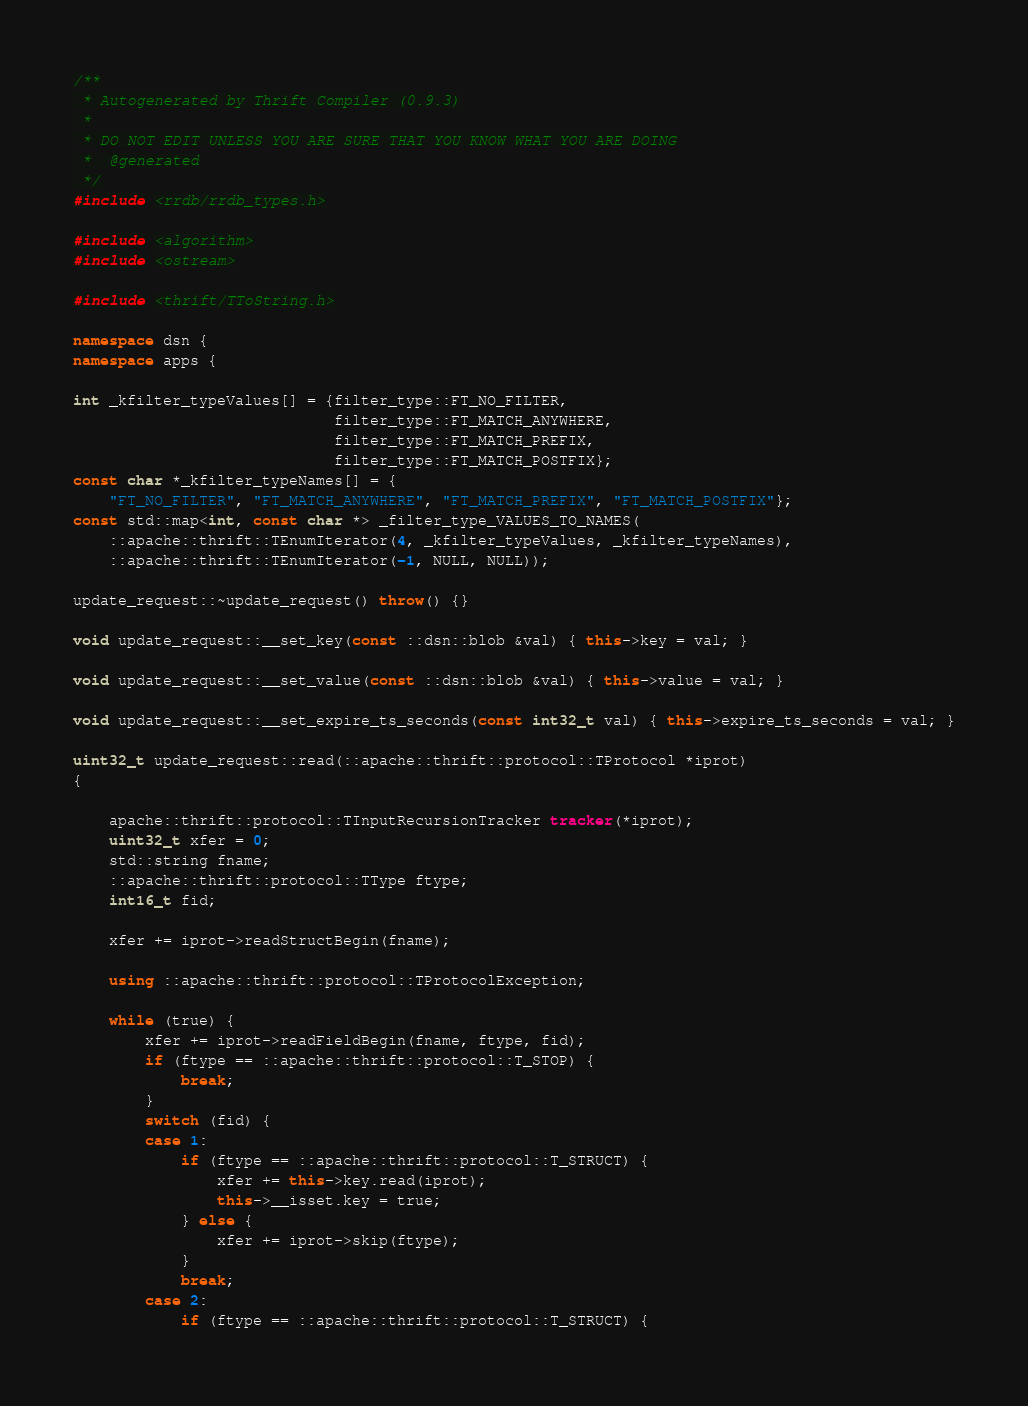Convert code to text. <code><loc_0><loc_0><loc_500><loc_500><_C++_>/**
 * Autogenerated by Thrift Compiler (0.9.3)
 *
 * DO NOT EDIT UNLESS YOU ARE SURE THAT YOU KNOW WHAT YOU ARE DOING
 *  @generated
 */
#include <rrdb/rrdb_types.h>

#include <algorithm>
#include <ostream>

#include <thrift/TToString.h>

namespace dsn {
namespace apps {

int _kfilter_typeValues[] = {filter_type::FT_NO_FILTER,
                             filter_type::FT_MATCH_ANYWHERE,
                             filter_type::FT_MATCH_PREFIX,
                             filter_type::FT_MATCH_POSTFIX};
const char *_kfilter_typeNames[] = {
    "FT_NO_FILTER", "FT_MATCH_ANYWHERE", "FT_MATCH_PREFIX", "FT_MATCH_POSTFIX"};
const std::map<int, const char *> _filter_type_VALUES_TO_NAMES(
    ::apache::thrift::TEnumIterator(4, _kfilter_typeValues, _kfilter_typeNames),
    ::apache::thrift::TEnumIterator(-1, NULL, NULL));

update_request::~update_request() throw() {}

void update_request::__set_key(const ::dsn::blob &val) { this->key = val; }

void update_request::__set_value(const ::dsn::blob &val) { this->value = val; }

void update_request::__set_expire_ts_seconds(const int32_t val) { this->expire_ts_seconds = val; }

uint32_t update_request::read(::apache::thrift::protocol::TProtocol *iprot)
{

    apache::thrift::protocol::TInputRecursionTracker tracker(*iprot);
    uint32_t xfer = 0;
    std::string fname;
    ::apache::thrift::protocol::TType ftype;
    int16_t fid;

    xfer += iprot->readStructBegin(fname);

    using ::apache::thrift::protocol::TProtocolException;

    while (true) {
        xfer += iprot->readFieldBegin(fname, ftype, fid);
        if (ftype == ::apache::thrift::protocol::T_STOP) {
            break;
        }
        switch (fid) {
        case 1:
            if (ftype == ::apache::thrift::protocol::T_STRUCT) {
                xfer += this->key.read(iprot);
                this->__isset.key = true;
            } else {
                xfer += iprot->skip(ftype);
            }
            break;
        case 2:
            if (ftype == ::apache::thrift::protocol::T_STRUCT) {</code> 